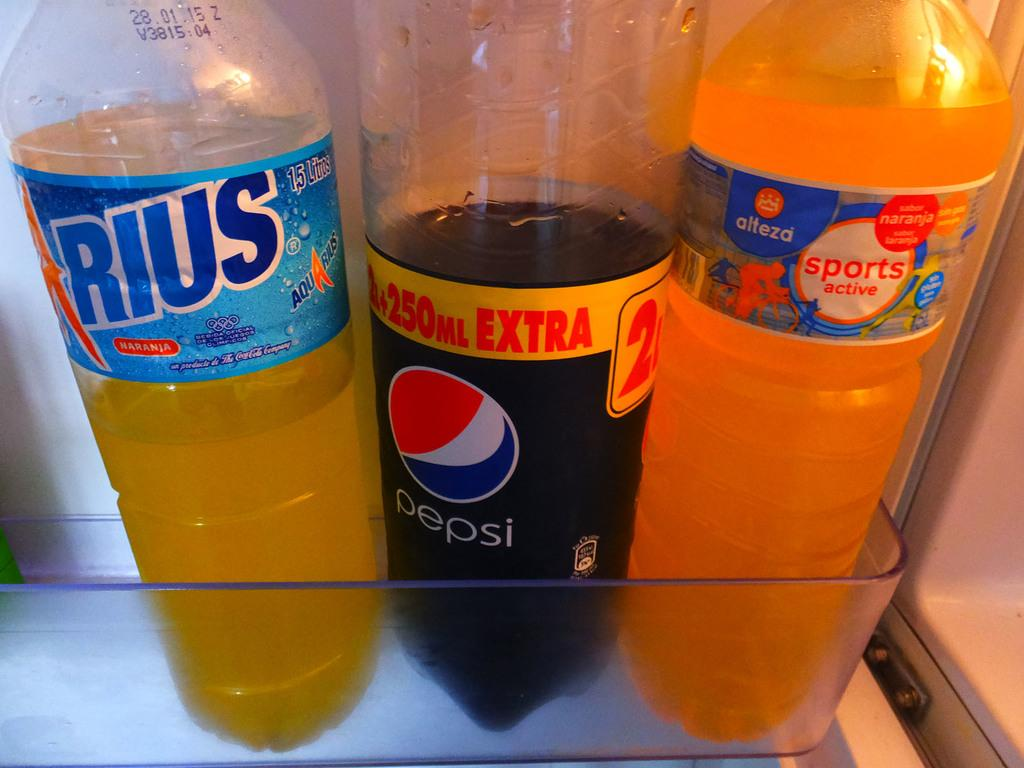<image>
Create a compact narrative representing the image presented. Three bottles partially filled with beverages are on a refrigerator shelf, including a Pepsi. 